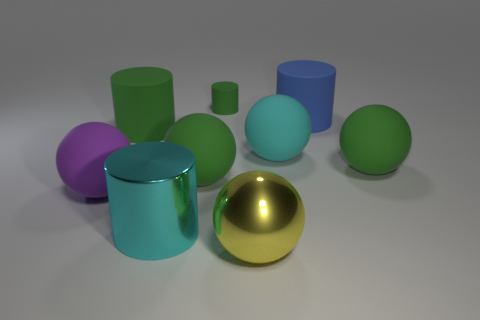There is a big shiny object that is the same shape as the large purple rubber thing; what is its color?
Your answer should be very brief. Yellow. What shape is the cyan thing in front of the cyan thing behind the large green matte sphere to the right of the blue matte cylinder?
Make the answer very short. Cylinder. Is the yellow shiny object the same shape as the purple rubber object?
Ensure brevity in your answer.  Yes. What shape is the metal thing that is to the left of the tiny cylinder that is behind the large cyan metal object?
Your answer should be compact. Cylinder. Are there any large yellow metal objects?
Offer a very short reply. Yes. How many green cylinders are on the left side of the big purple rubber sphere that is behind the metal object on the left side of the yellow metallic thing?
Ensure brevity in your answer.  0. Do the big blue object and the big green thing to the right of the large yellow metallic thing have the same shape?
Your response must be concise. No. Are there more large blue matte cylinders than brown objects?
Your answer should be compact. Yes. Do the green rubber thing to the left of the big cyan cylinder and the purple object have the same shape?
Make the answer very short. No. Are there more large things in front of the metal cylinder than blue metal balls?
Ensure brevity in your answer.  Yes. 